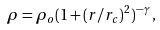<formula> <loc_0><loc_0><loc_500><loc_500>\rho = \rho _ { o } ( 1 + ( r / r _ { c } ) ^ { 2 } ) ^ { - \gamma } \, ,</formula> 